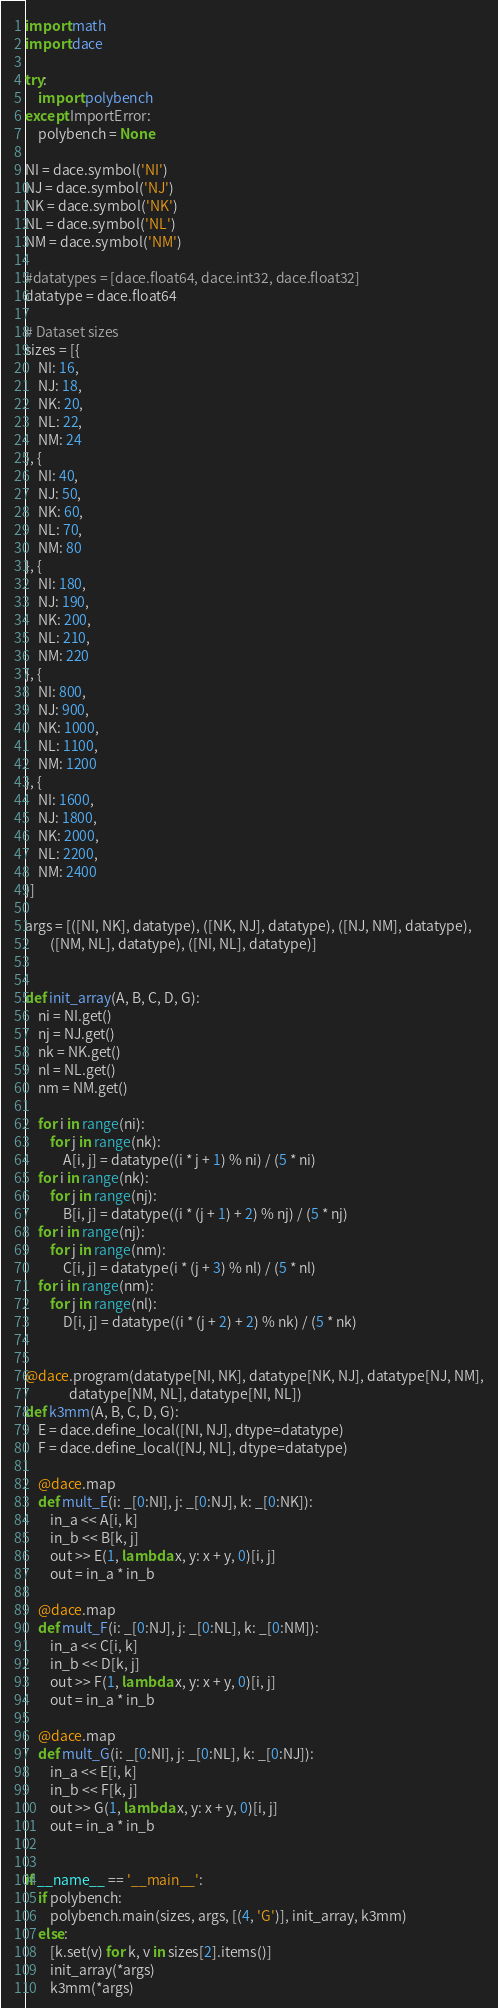Convert code to text. <code><loc_0><loc_0><loc_500><loc_500><_Python_>import math
import dace

try:
    import polybench
except ImportError:
    polybench = None

NI = dace.symbol('NI')
NJ = dace.symbol('NJ')
NK = dace.symbol('NK')
NL = dace.symbol('NL')
NM = dace.symbol('NM')

#datatypes = [dace.float64, dace.int32, dace.float32]
datatype = dace.float64

# Dataset sizes
sizes = [{
    NI: 16,
    NJ: 18,
    NK: 20,
    NL: 22,
    NM: 24
}, {
    NI: 40,
    NJ: 50,
    NK: 60,
    NL: 70,
    NM: 80
}, {
    NI: 180,
    NJ: 190,
    NK: 200,
    NL: 210,
    NM: 220
}, {
    NI: 800,
    NJ: 900,
    NK: 1000,
    NL: 1100,
    NM: 1200
}, {
    NI: 1600,
    NJ: 1800,
    NK: 2000,
    NL: 2200,
    NM: 2400
}]

args = [([NI, NK], datatype), ([NK, NJ], datatype), ([NJ, NM], datatype),
        ([NM, NL], datatype), ([NI, NL], datatype)]


def init_array(A, B, C, D, G):
    ni = NI.get()
    nj = NJ.get()
    nk = NK.get()
    nl = NL.get()
    nm = NM.get()

    for i in range(ni):
        for j in range(nk):
            A[i, j] = datatype((i * j + 1) % ni) / (5 * ni)
    for i in range(nk):
        for j in range(nj):
            B[i, j] = datatype((i * (j + 1) + 2) % nj) / (5 * nj)
    for i in range(nj):
        for j in range(nm):
            C[i, j] = datatype(i * (j + 3) % nl) / (5 * nl)
    for i in range(nm):
        for j in range(nl):
            D[i, j] = datatype((i * (j + 2) + 2) % nk) / (5 * nk)


@dace.program(datatype[NI, NK], datatype[NK, NJ], datatype[NJ, NM],
              datatype[NM, NL], datatype[NI, NL])
def k3mm(A, B, C, D, G):
    E = dace.define_local([NI, NJ], dtype=datatype)
    F = dace.define_local([NJ, NL], dtype=datatype)

    @dace.map
    def mult_E(i: _[0:NI], j: _[0:NJ], k: _[0:NK]):
        in_a << A[i, k]
        in_b << B[k, j]
        out >> E(1, lambda x, y: x + y, 0)[i, j]
        out = in_a * in_b

    @dace.map
    def mult_F(i: _[0:NJ], j: _[0:NL], k: _[0:NM]):
        in_a << C[i, k]
        in_b << D[k, j]
        out >> F(1, lambda x, y: x + y, 0)[i, j]
        out = in_a * in_b

    @dace.map
    def mult_G(i: _[0:NI], j: _[0:NL], k: _[0:NJ]):
        in_a << E[i, k]
        in_b << F[k, j]
        out >> G(1, lambda x, y: x + y, 0)[i, j]
        out = in_a * in_b


if __name__ == '__main__':
    if polybench:
        polybench.main(sizes, args, [(4, 'G')], init_array, k3mm)
    else:
        [k.set(v) for k, v in sizes[2].items()]
        init_array(*args)
        k3mm(*args)
</code> 